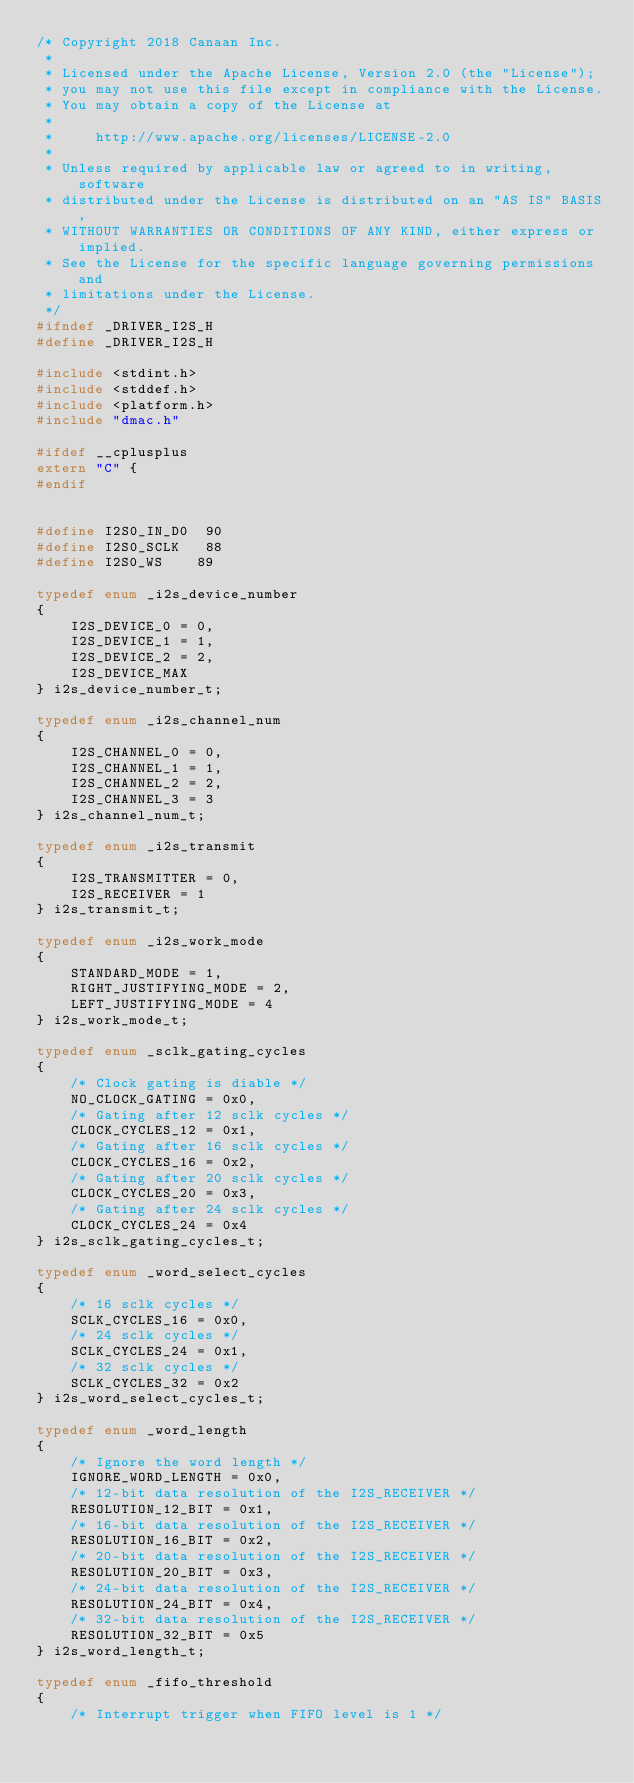<code> <loc_0><loc_0><loc_500><loc_500><_C_>/* Copyright 2018 Canaan Inc.
 *
 * Licensed under the Apache License, Version 2.0 (the "License");
 * you may not use this file except in compliance with the License.
 * You may obtain a copy of the License at
 *
 *     http://www.apache.org/licenses/LICENSE-2.0
 *
 * Unless required by applicable law or agreed to in writing, software
 * distributed under the License is distributed on an "AS IS" BASIS,
 * WITHOUT WARRANTIES OR CONDITIONS OF ANY KIND, either express or implied.
 * See the License for the specific language governing permissions and
 * limitations under the License.
 */
#ifndef _DRIVER_I2S_H
#define _DRIVER_I2S_H

#include <stdint.h>
#include <stddef.h>
#include <platform.h>
#include "dmac.h"

#ifdef __cplusplus
extern "C" {
#endif


#define I2S0_IN_D0  90
#define I2S0_SCLK   88
#define I2S0_WS    89

typedef enum _i2s_device_number
{
    I2S_DEVICE_0 = 0,
    I2S_DEVICE_1 = 1,
    I2S_DEVICE_2 = 2,
    I2S_DEVICE_MAX
} i2s_device_number_t;

typedef enum _i2s_channel_num
{
    I2S_CHANNEL_0 = 0,
    I2S_CHANNEL_1 = 1,
    I2S_CHANNEL_2 = 2,
    I2S_CHANNEL_3 = 3
} i2s_channel_num_t;

typedef enum _i2s_transmit
{
    I2S_TRANSMITTER = 0,
    I2S_RECEIVER = 1
} i2s_transmit_t;

typedef enum _i2s_work_mode
{
    STANDARD_MODE = 1,
    RIGHT_JUSTIFYING_MODE = 2,
    LEFT_JUSTIFYING_MODE = 4
} i2s_work_mode_t;

typedef enum _sclk_gating_cycles
{
    /* Clock gating is diable */
    NO_CLOCK_GATING = 0x0,
    /* Gating after 12 sclk cycles */
    CLOCK_CYCLES_12 = 0x1,
    /* Gating after 16 sclk cycles */
    CLOCK_CYCLES_16 = 0x2,
    /* Gating after 20 sclk cycles */
    CLOCK_CYCLES_20 = 0x3,
    /* Gating after 24 sclk cycles */
    CLOCK_CYCLES_24 = 0x4
} i2s_sclk_gating_cycles_t;

typedef enum _word_select_cycles
{
    /* 16 sclk cycles */
    SCLK_CYCLES_16 = 0x0,
    /* 24 sclk cycles */
    SCLK_CYCLES_24 = 0x1,
    /* 32 sclk cycles */
    SCLK_CYCLES_32 = 0x2
} i2s_word_select_cycles_t;

typedef enum _word_length
{
    /* Ignore the word length */
    IGNORE_WORD_LENGTH = 0x0,
    /* 12-bit data resolution of the I2S_RECEIVER */
    RESOLUTION_12_BIT = 0x1,
    /* 16-bit data resolution of the I2S_RECEIVER */
    RESOLUTION_16_BIT = 0x2,
    /* 20-bit data resolution of the I2S_RECEIVER */
    RESOLUTION_20_BIT = 0x3,
    /* 24-bit data resolution of the I2S_RECEIVER */
    RESOLUTION_24_BIT = 0x4,
    /* 32-bit data resolution of the I2S_RECEIVER */
    RESOLUTION_32_BIT = 0x5
} i2s_word_length_t;

typedef enum _fifo_threshold
{
    /* Interrupt trigger when FIFO level is 1 */</code> 